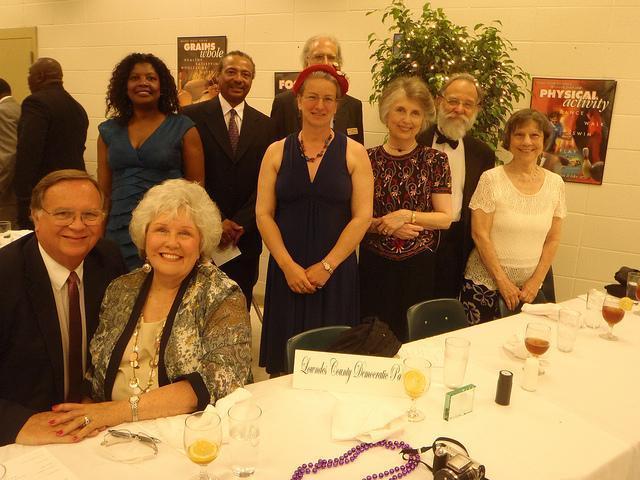How many people are raising hands?
Give a very brief answer. 0. How many people can be seen?
Give a very brief answer. 10. How many green spray bottles are there?
Give a very brief answer. 0. 